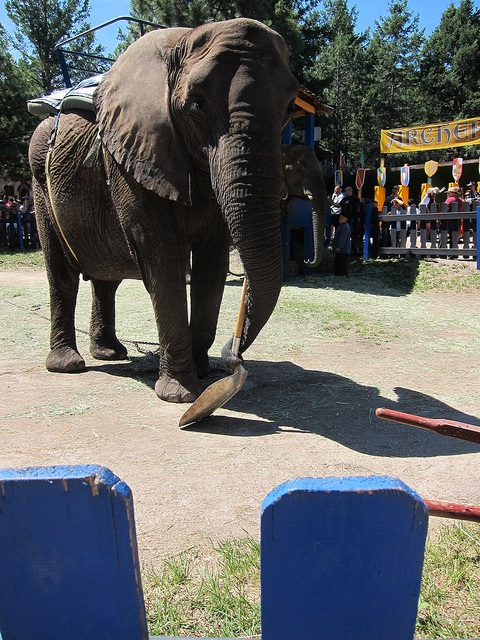Please extract the text content from this image. ARCKER 